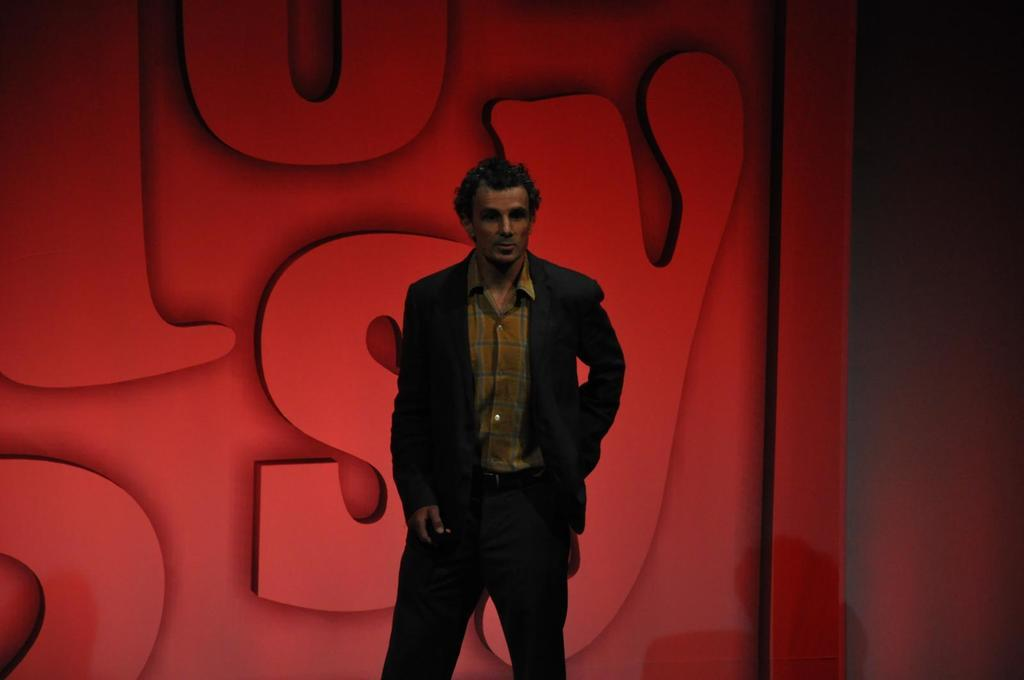Who or what is present in the image? There is a person in the image. What can be seen behind the person in the image? There is a red color wall in the background of the image. Are there any words or letters visible on the red wall? Yes, there are letters on the red wall. How many tomatoes can be seen growing on the farm in the image? There is no farm or tomatoes present in the image; it features a person in front of a red wall with letters. Is there a bubble floating near the person in the image? There is no bubble visible in the image. 